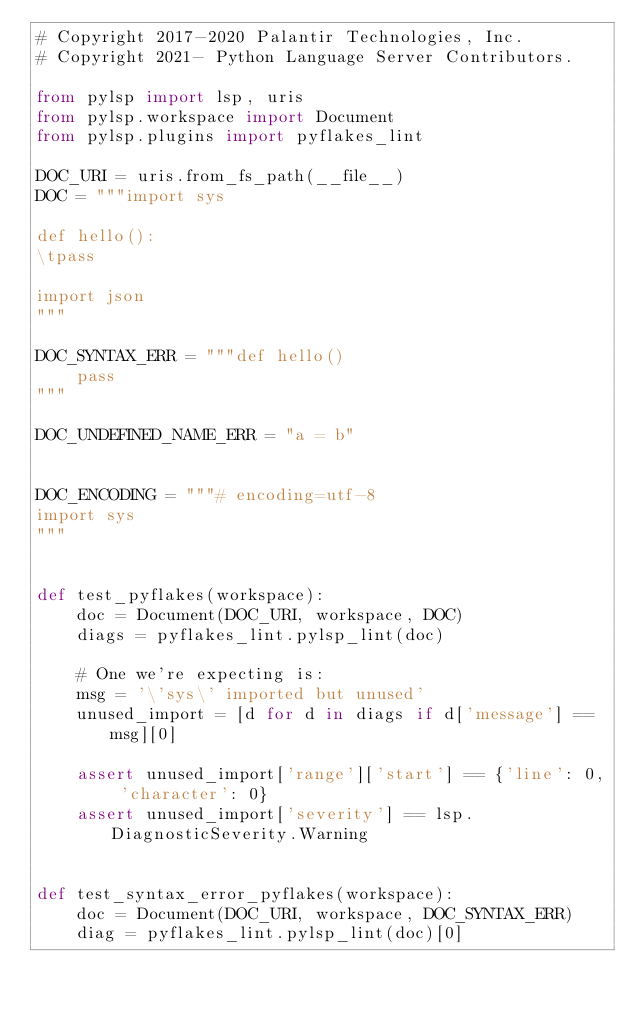Convert code to text. <code><loc_0><loc_0><loc_500><loc_500><_Python_># Copyright 2017-2020 Palantir Technologies, Inc.
# Copyright 2021- Python Language Server Contributors.

from pylsp import lsp, uris
from pylsp.workspace import Document
from pylsp.plugins import pyflakes_lint

DOC_URI = uris.from_fs_path(__file__)
DOC = """import sys

def hello():
\tpass

import json
"""

DOC_SYNTAX_ERR = """def hello()
    pass
"""

DOC_UNDEFINED_NAME_ERR = "a = b"


DOC_ENCODING = """# encoding=utf-8
import sys
"""


def test_pyflakes(workspace):
    doc = Document(DOC_URI, workspace, DOC)
    diags = pyflakes_lint.pylsp_lint(doc)

    # One we're expecting is:
    msg = '\'sys\' imported but unused'
    unused_import = [d for d in diags if d['message'] == msg][0]

    assert unused_import['range']['start'] == {'line': 0, 'character': 0}
    assert unused_import['severity'] == lsp.DiagnosticSeverity.Warning


def test_syntax_error_pyflakes(workspace):
    doc = Document(DOC_URI, workspace, DOC_SYNTAX_ERR)
    diag = pyflakes_lint.pylsp_lint(doc)[0]
</code> 